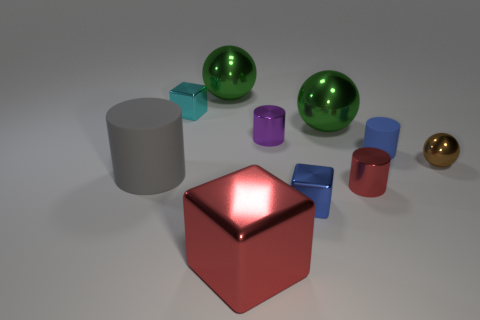Subtract all spheres. How many objects are left? 7 Add 1 cyan things. How many cyan things are left? 2 Add 2 small blue shiny balls. How many small blue shiny balls exist? 2 Subtract 1 blue cubes. How many objects are left? 9 Subtract all green shiny balls. Subtract all small metallic spheres. How many objects are left? 7 